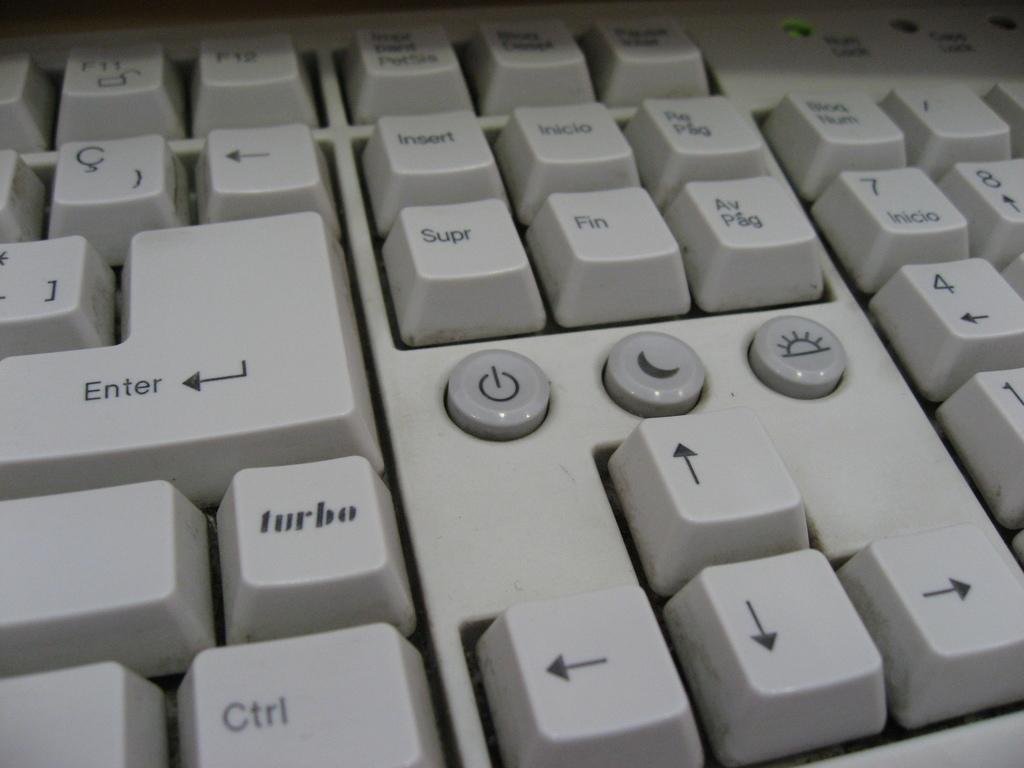Which key is below the enter key?
Your response must be concise. Turbo. What are the 4 numbers shown on the keyboard?
Offer a very short reply. 1478. 